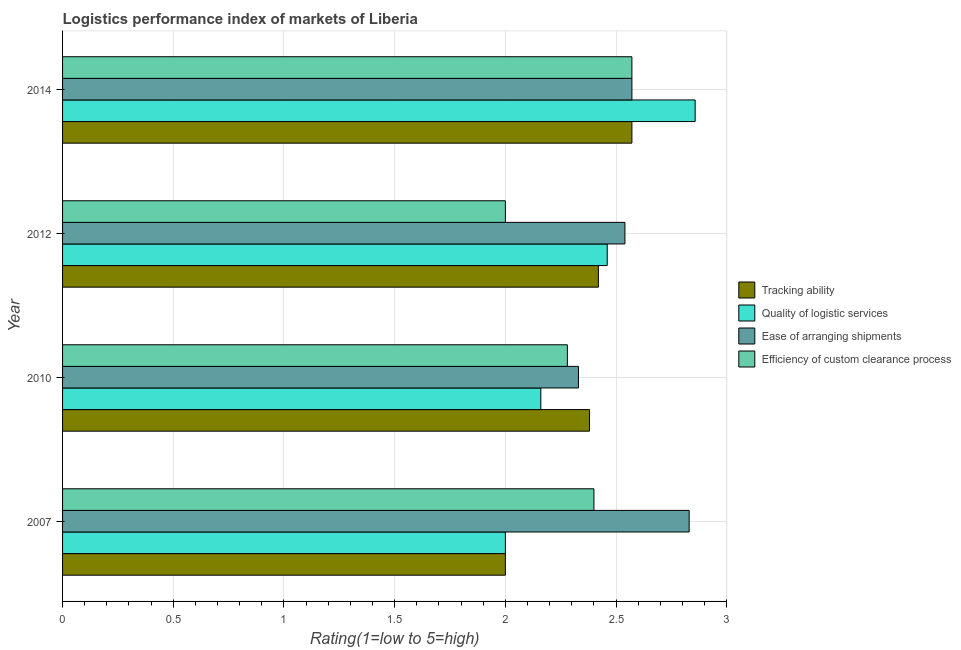How many groups of bars are there?
Keep it short and to the point. 4. Are the number of bars on each tick of the Y-axis equal?
Give a very brief answer. Yes. What is the lpi rating of quality of logistic services in 2012?
Make the answer very short. 2.46. Across all years, what is the maximum lpi rating of ease of arranging shipments?
Offer a very short reply. 2.83. In which year was the lpi rating of ease of arranging shipments minimum?
Provide a succinct answer. 2010. What is the total lpi rating of tracking ability in the graph?
Offer a terse response. 9.37. What is the difference between the lpi rating of tracking ability in 2007 and that in 2010?
Offer a terse response. -0.38. What is the difference between the lpi rating of quality of logistic services in 2012 and the lpi rating of efficiency of custom clearance process in 2014?
Offer a terse response. -0.11. What is the average lpi rating of tracking ability per year?
Keep it short and to the point. 2.34. In the year 2012, what is the difference between the lpi rating of tracking ability and lpi rating of ease of arranging shipments?
Provide a short and direct response. -0.12. What is the ratio of the lpi rating of quality of logistic services in 2012 to that in 2014?
Provide a succinct answer. 0.86. Is the difference between the lpi rating of quality of logistic services in 2012 and 2014 greater than the difference between the lpi rating of efficiency of custom clearance process in 2012 and 2014?
Keep it short and to the point. Yes. What is the difference between the highest and the second highest lpi rating of tracking ability?
Your response must be concise. 0.15. What is the difference between the highest and the lowest lpi rating of quality of logistic services?
Your answer should be very brief. 0.86. In how many years, is the lpi rating of quality of logistic services greater than the average lpi rating of quality of logistic services taken over all years?
Offer a very short reply. 2. Is the sum of the lpi rating of tracking ability in 2007 and 2014 greater than the maximum lpi rating of ease of arranging shipments across all years?
Provide a short and direct response. Yes. Is it the case that in every year, the sum of the lpi rating of efficiency of custom clearance process and lpi rating of quality of logistic services is greater than the sum of lpi rating of tracking ability and lpi rating of ease of arranging shipments?
Offer a terse response. No. What does the 2nd bar from the top in 2010 represents?
Your answer should be very brief. Ease of arranging shipments. What does the 1st bar from the bottom in 2012 represents?
Your answer should be compact. Tracking ability. Are all the bars in the graph horizontal?
Offer a terse response. Yes. How many years are there in the graph?
Offer a very short reply. 4. Does the graph contain any zero values?
Ensure brevity in your answer.  No. Does the graph contain grids?
Keep it short and to the point. Yes. How many legend labels are there?
Offer a very short reply. 4. How are the legend labels stacked?
Make the answer very short. Vertical. What is the title of the graph?
Ensure brevity in your answer.  Logistics performance index of markets of Liberia. Does "Public resource use" appear as one of the legend labels in the graph?
Offer a very short reply. No. What is the label or title of the X-axis?
Make the answer very short. Rating(1=low to 5=high). What is the label or title of the Y-axis?
Make the answer very short. Year. What is the Rating(1=low to 5=high) in Tracking ability in 2007?
Give a very brief answer. 2. What is the Rating(1=low to 5=high) of Quality of logistic services in 2007?
Give a very brief answer. 2. What is the Rating(1=low to 5=high) of Ease of arranging shipments in 2007?
Offer a terse response. 2.83. What is the Rating(1=low to 5=high) in Efficiency of custom clearance process in 2007?
Give a very brief answer. 2.4. What is the Rating(1=low to 5=high) in Tracking ability in 2010?
Keep it short and to the point. 2.38. What is the Rating(1=low to 5=high) in Quality of logistic services in 2010?
Provide a succinct answer. 2.16. What is the Rating(1=low to 5=high) in Ease of arranging shipments in 2010?
Your response must be concise. 2.33. What is the Rating(1=low to 5=high) of Efficiency of custom clearance process in 2010?
Keep it short and to the point. 2.28. What is the Rating(1=low to 5=high) of Tracking ability in 2012?
Make the answer very short. 2.42. What is the Rating(1=low to 5=high) of Quality of logistic services in 2012?
Give a very brief answer. 2.46. What is the Rating(1=low to 5=high) in Ease of arranging shipments in 2012?
Keep it short and to the point. 2.54. What is the Rating(1=low to 5=high) in Efficiency of custom clearance process in 2012?
Offer a very short reply. 2. What is the Rating(1=low to 5=high) in Tracking ability in 2014?
Your answer should be compact. 2.57. What is the Rating(1=low to 5=high) of Quality of logistic services in 2014?
Provide a succinct answer. 2.86. What is the Rating(1=low to 5=high) in Ease of arranging shipments in 2014?
Offer a very short reply. 2.57. What is the Rating(1=low to 5=high) in Efficiency of custom clearance process in 2014?
Ensure brevity in your answer.  2.57. Across all years, what is the maximum Rating(1=low to 5=high) of Tracking ability?
Keep it short and to the point. 2.57. Across all years, what is the maximum Rating(1=low to 5=high) in Quality of logistic services?
Ensure brevity in your answer.  2.86. Across all years, what is the maximum Rating(1=low to 5=high) in Ease of arranging shipments?
Provide a succinct answer. 2.83. Across all years, what is the maximum Rating(1=low to 5=high) of Efficiency of custom clearance process?
Provide a succinct answer. 2.57. Across all years, what is the minimum Rating(1=low to 5=high) in Ease of arranging shipments?
Your answer should be very brief. 2.33. Across all years, what is the minimum Rating(1=low to 5=high) of Efficiency of custom clearance process?
Offer a terse response. 2. What is the total Rating(1=low to 5=high) of Tracking ability in the graph?
Offer a terse response. 9.37. What is the total Rating(1=low to 5=high) of Quality of logistic services in the graph?
Keep it short and to the point. 9.48. What is the total Rating(1=low to 5=high) of Ease of arranging shipments in the graph?
Your response must be concise. 10.27. What is the total Rating(1=low to 5=high) of Efficiency of custom clearance process in the graph?
Keep it short and to the point. 9.25. What is the difference between the Rating(1=low to 5=high) of Tracking ability in 2007 and that in 2010?
Keep it short and to the point. -0.38. What is the difference between the Rating(1=low to 5=high) in Quality of logistic services in 2007 and that in 2010?
Give a very brief answer. -0.16. What is the difference between the Rating(1=low to 5=high) in Ease of arranging shipments in 2007 and that in 2010?
Provide a short and direct response. 0.5. What is the difference between the Rating(1=low to 5=high) of Efficiency of custom clearance process in 2007 and that in 2010?
Give a very brief answer. 0.12. What is the difference between the Rating(1=low to 5=high) of Tracking ability in 2007 and that in 2012?
Your answer should be compact. -0.42. What is the difference between the Rating(1=low to 5=high) in Quality of logistic services in 2007 and that in 2012?
Ensure brevity in your answer.  -0.46. What is the difference between the Rating(1=low to 5=high) in Ease of arranging shipments in 2007 and that in 2012?
Provide a succinct answer. 0.29. What is the difference between the Rating(1=low to 5=high) in Efficiency of custom clearance process in 2007 and that in 2012?
Ensure brevity in your answer.  0.4. What is the difference between the Rating(1=low to 5=high) of Tracking ability in 2007 and that in 2014?
Your response must be concise. -0.57. What is the difference between the Rating(1=low to 5=high) in Quality of logistic services in 2007 and that in 2014?
Provide a succinct answer. -0.86. What is the difference between the Rating(1=low to 5=high) in Ease of arranging shipments in 2007 and that in 2014?
Your answer should be compact. 0.26. What is the difference between the Rating(1=low to 5=high) in Efficiency of custom clearance process in 2007 and that in 2014?
Offer a very short reply. -0.17. What is the difference between the Rating(1=low to 5=high) in Tracking ability in 2010 and that in 2012?
Keep it short and to the point. -0.04. What is the difference between the Rating(1=low to 5=high) of Ease of arranging shipments in 2010 and that in 2012?
Your response must be concise. -0.21. What is the difference between the Rating(1=low to 5=high) in Efficiency of custom clearance process in 2010 and that in 2012?
Provide a succinct answer. 0.28. What is the difference between the Rating(1=low to 5=high) in Tracking ability in 2010 and that in 2014?
Offer a very short reply. -0.19. What is the difference between the Rating(1=low to 5=high) in Quality of logistic services in 2010 and that in 2014?
Provide a succinct answer. -0.7. What is the difference between the Rating(1=low to 5=high) in Ease of arranging shipments in 2010 and that in 2014?
Your answer should be compact. -0.24. What is the difference between the Rating(1=low to 5=high) of Efficiency of custom clearance process in 2010 and that in 2014?
Give a very brief answer. -0.29. What is the difference between the Rating(1=low to 5=high) of Tracking ability in 2012 and that in 2014?
Offer a very short reply. -0.15. What is the difference between the Rating(1=low to 5=high) in Quality of logistic services in 2012 and that in 2014?
Make the answer very short. -0.4. What is the difference between the Rating(1=low to 5=high) of Ease of arranging shipments in 2012 and that in 2014?
Make the answer very short. -0.03. What is the difference between the Rating(1=low to 5=high) of Efficiency of custom clearance process in 2012 and that in 2014?
Your answer should be compact. -0.57. What is the difference between the Rating(1=low to 5=high) of Tracking ability in 2007 and the Rating(1=low to 5=high) of Quality of logistic services in 2010?
Give a very brief answer. -0.16. What is the difference between the Rating(1=low to 5=high) in Tracking ability in 2007 and the Rating(1=low to 5=high) in Ease of arranging shipments in 2010?
Your response must be concise. -0.33. What is the difference between the Rating(1=low to 5=high) in Tracking ability in 2007 and the Rating(1=low to 5=high) in Efficiency of custom clearance process in 2010?
Ensure brevity in your answer.  -0.28. What is the difference between the Rating(1=low to 5=high) in Quality of logistic services in 2007 and the Rating(1=low to 5=high) in Ease of arranging shipments in 2010?
Make the answer very short. -0.33. What is the difference between the Rating(1=low to 5=high) in Quality of logistic services in 2007 and the Rating(1=low to 5=high) in Efficiency of custom clearance process in 2010?
Your answer should be very brief. -0.28. What is the difference between the Rating(1=low to 5=high) of Ease of arranging shipments in 2007 and the Rating(1=low to 5=high) of Efficiency of custom clearance process in 2010?
Ensure brevity in your answer.  0.55. What is the difference between the Rating(1=low to 5=high) of Tracking ability in 2007 and the Rating(1=low to 5=high) of Quality of logistic services in 2012?
Offer a very short reply. -0.46. What is the difference between the Rating(1=low to 5=high) in Tracking ability in 2007 and the Rating(1=low to 5=high) in Ease of arranging shipments in 2012?
Provide a succinct answer. -0.54. What is the difference between the Rating(1=low to 5=high) of Quality of logistic services in 2007 and the Rating(1=low to 5=high) of Ease of arranging shipments in 2012?
Offer a terse response. -0.54. What is the difference between the Rating(1=low to 5=high) in Quality of logistic services in 2007 and the Rating(1=low to 5=high) in Efficiency of custom clearance process in 2012?
Provide a short and direct response. 0. What is the difference between the Rating(1=low to 5=high) in Ease of arranging shipments in 2007 and the Rating(1=low to 5=high) in Efficiency of custom clearance process in 2012?
Your response must be concise. 0.83. What is the difference between the Rating(1=low to 5=high) in Tracking ability in 2007 and the Rating(1=low to 5=high) in Quality of logistic services in 2014?
Keep it short and to the point. -0.86. What is the difference between the Rating(1=low to 5=high) in Tracking ability in 2007 and the Rating(1=low to 5=high) in Ease of arranging shipments in 2014?
Provide a short and direct response. -0.57. What is the difference between the Rating(1=low to 5=high) of Tracking ability in 2007 and the Rating(1=low to 5=high) of Efficiency of custom clearance process in 2014?
Give a very brief answer. -0.57. What is the difference between the Rating(1=low to 5=high) in Quality of logistic services in 2007 and the Rating(1=low to 5=high) in Ease of arranging shipments in 2014?
Ensure brevity in your answer.  -0.57. What is the difference between the Rating(1=low to 5=high) in Quality of logistic services in 2007 and the Rating(1=low to 5=high) in Efficiency of custom clearance process in 2014?
Offer a very short reply. -0.57. What is the difference between the Rating(1=low to 5=high) of Ease of arranging shipments in 2007 and the Rating(1=low to 5=high) of Efficiency of custom clearance process in 2014?
Make the answer very short. 0.26. What is the difference between the Rating(1=low to 5=high) of Tracking ability in 2010 and the Rating(1=low to 5=high) of Quality of logistic services in 2012?
Your answer should be very brief. -0.08. What is the difference between the Rating(1=low to 5=high) of Tracking ability in 2010 and the Rating(1=low to 5=high) of Ease of arranging shipments in 2012?
Provide a succinct answer. -0.16. What is the difference between the Rating(1=low to 5=high) of Tracking ability in 2010 and the Rating(1=low to 5=high) of Efficiency of custom clearance process in 2012?
Give a very brief answer. 0.38. What is the difference between the Rating(1=low to 5=high) in Quality of logistic services in 2010 and the Rating(1=low to 5=high) in Ease of arranging shipments in 2012?
Offer a terse response. -0.38. What is the difference between the Rating(1=low to 5=high) of Quality of logistic services in 2010 and the Rating(1=low to 5=high) of Efficiency of custom clearance process in 2012?
Keep it short and to the point. 0.16. What is the difference between the Rating(1=low to 5=high) in Ease of arranging shipments in 2010 and the Rating(1=low to 5=high) in Efficiency of custom clearance process in 2012?
Make the answer very short. 0.33. What is the difference between the Rating(1=low to 5=high) of Tracking ability in 2010 and the Rating(1=low to 5=high) of Quality of logistic services in 2014?
Provide a succinct answer. -0.48. What is the difference between the Rating(1=low to 5=high) of Tracking ability in 2010 and the Rating(1=low to 5=high) of Ease of arranging shipments in 2014?
Your response must be concise. -0.19. What is the difference between the Rating(1=low to 5=high) of Tracking ability in 2010 and the Rating(1=low to 5=high) of Efficiency of custom clearance process in 2014?
Provide a succinct answer. -0.19. What is the difference between the Rating(1=low to 5=high) of Quality of logistic services in 2010 and the Rating(1=low to 5=high) of Ease of arranging shipments in 2014?
Offer a terse response. -0.41. What is the difference between the Rating(1=low to 5=high) of Quality of logistic services in 2010 and the Rating(1=low to 5=high) of Efficiency of custom clearance process in 2014?
Your answer should be very brief. -0.41. What is the difference between the Rating(1=low to 5=high) of Ease of arranging shipments in 2010 and the Rating(1=low to 5=high) of Efficiency of custom clearance process in 2014?
Ensure brevity in your answer.  -0.24. What is the difference between the Rating(1=low to 5=high) in Tracking ability in 2012 and the Rating(1=low to 5=high) in Quality of logistic services in 2014?
Your answer should be compact. -0.44. What is the difference between the Rating(1=low to 5=high) in Tracking ability in 2012 and the Rating(1=low to 5=high) in Ease of arranging shipments in 2014?
Provide a short and direct response. -0.15. What is the difference between the Rating(1=low to 5=high) of Tracking ability in 2012 and the Rating(1=low to 5=high) of Efficiency of custom clearance process in 2014?
Your answer should be compact. -0.15. What is the difference between the Rating(1=low to 5=high) of Quality of logistic services in 2012 and the Rating(1=low to 5=high) of Ease of arranging shipments in 2014?
Offer a very short reply. -0.11. What is the difference between the Rating(1=low to 5=high) of Quality of logistic services in 2012 and the Rating(1=low to 5=high) of Efficiency of custom clearance process in 2014?
Ensure brevity in your answer.  -0.11. What is the difference between the Rating(1=low to 5=high) in Ease of arranging shipments in 2012 and the Rating(1=low to 5=high) in Efficiency of custom clearance process in 2014?
Provide a succinct answer. -0.03. What is the average Rating(1=low to 5=high) in Tracking ability per year?
Give a very brief answer. 2.34. What is the average Rating(1=low to 5=high) in Quality of logistic services per year?
Your response must be concise. 2.37. What is the average Rating(1=low to 5=high) of Ease of arranging shipments per year?
Offer a terse response. 2.57. What is the average Rating(1=low to 5=high) in Efficiency of custom clearance process per year?
Ensure brevity in your answer.  2.31. In the year 2007, what is the difference between the Rating(1=low to 5=high) in Tracking ability and Rating(1=low to 5=high) in Quality of logistic services?
Ensure brevity in your answer.  0. In the year 2007, what is the difference between the Rating(1=low to 5=high) of Tracking ability and Rating(1=low to 5=high) of Ease of arranging shipments?
Provide a succinct answer. -0.83. In the year 2007, what is the difference between the Rating(1=low to 5=high) in Tracking ability and Rating(1=low to 5=high) in Efficiency of custom clearance process?
Offer a terse response. -0.4. In the year 2007, what is the difference between the Rating(1=low to 5=high) in Quality of logistic services and Rating(1=low to 5=high) in Ease of arranging shipments?
Give a very brief answer. -0.83. In the year 2007, what is the difference between the Rating(1=low to 5=high) of Ease of arranging shipments and Rating(1=low to 5=high) of Efficiency of custom clearance process?
Ensure brevity in your answer.  0.43. In the year 2010, what is the difference between the Rating(1=low to 5=high) of Tracking ability and Rating(1=low to 5=high) of Quality of logistic services?
Offer a terse response. 0.22. In the year 2010, what is the difference between the Rating(1=low to 5=high) in Tracking ability and Rating(1=low to 5=high) in Efficiency of custom clearance process?
Provide a succinct answer. 0.1. In the year 2010, what is the difference between the Rating(1=low to 5=high) of Quality of logistic services and Rating(1=low to 5=high) of Ease of arranging shipments?
Make the answer very short. -0.17. In the year 2010, what is the difference between the Rating(1=low to 5=high) of Quality of logistic services and Rating(1=low to 5=high) of Efficiency of custom clearance process?
Keep it short and to the point. -0.12. In the year 2012, what is the difference between the Rating(1=low to 5=high) in Tracking ability and Rating(1=low to 5=high) in Quality of logistic services?
Offer a terse response. -0.04. In the year 2012, what is the difference between the Rating(1=low to 5=high) of Tracking ability and Rating(1=low to 5=high) of Ease of arranging shipments?
Your answer should be very brief. -0.12. In the year 2012, what is the difference between the Rating(1=low to 5=high) of Tracking ability and Rating(1=low to 5=high) of Efficiency of custom clearance process?
Offer a terse response. 0.42. In the year 2012, what is the difference between the Rating(1=low to 5=high) in Quality of logistic services and Rating(1=low to 5=high) in Ease of arranging shipments?
Ensure brevity in your answer.  -0.08. In the year 2012, what is the difference between the Rating(1=low to 5=high) in Quality of logistic services and Rating(1=low to 5=high) in Efficiency of custom clearance process?
Give a very brief answer. 0.46. In the year 2012, what is the difference between the Rating(1=low to 5=high) of Ease of arranging shipments and Rating(1=low to 5=high) of Efficiency of custom clearance process?
Provide a succinct answer. 0.54. In the year 2014, what is the difference between the Rating(1=low to 5=high) of Tracking ability and Rating(1=low to 5=high) of Quality of logistic services?
Your answer should be very brief. -0.29. In the year 2014, what is the difference between the Rating(1=low to 5=high) in Tracking ability and Rating(1=low to 5=high) in Ease of arranging shipments?
Provide a succinct answer. 0. In the year 2014, what is the difference between the Rating(1=low to 5=high) of Tracking ability and Rating(1=low to 5=high) of Efficiency of custom clearance process?
Your answer should be very brief. 0. In the year 2014, what is the difference between the Rating(1=low to 5=high) of Quality of logistic services and Rating(1=low to 5=high) of Ease of arranging shipments?
Offer a terse response. 0.29. In the year 2014, what is the difference between the Rating(1=low to 5=high) in Quality of logistic services and Rating(1=low to 5=high) in Efficiency of custom clearance process?
Give a very brief answer. 0.29. In the year 2014, what is the difference between the Rating(1=low to 5=high) of Ease of arranging shipments and Rating(1=low to 5=high) of Efficiency of custom clearance process?
Give a very brief answer. 0. What is the ratio of the Rating(1=low to 5=high) in Tracking ability in 2007 to that in 2010?
Make the answer very short. 0.84. What is the ratio of the Rating(1=low to 5=high) in Quality of logistic services in 2007 to that in 2010?
Provide a succinct answer. 0.93. What is the ratio of the Rating(1=low to 5=high) in Ease of arranging shipments in 2007 to that in 2010?
Keep it short and to the point. 1.21. What is the ratio of the Rating(1=low to 5=high) of Efficiency of custom clearance process in 2007 to that in 2010?
Your answer should be very brief. 1.05. What is the ratio of the Rating(1=low to 5=high) of Tracking ability in 2007 to that in 2012?
Provide a short and direct response. 0.83. What is the ratio of the Rating(1=low to 5=high) of Quality of logistic services in 2007 to that in 2012?
Your answer should be compact. 0.81. What is the ratio of the Rating(1=low to 5=high) in Ease of arranging shipments in 2007 to that in 2012?
Offer a terse response. 1.11. What is the ratio of the Rating(1=low to 5=high) of Tracking ability in 2007 to that in 2014?
Ensure brevity in your answer.  0.78. What is the ratio of the Rating(1=low to 5=high) in Ease of arranging shipments in 2007 to that in 2014?
Offer a terse response. 1.1. What is the ratio of the Rating(1=low to 5=high) in Tracking ability in 2010 to that in 2012?
Your answer should be very brief. 0.98. What is the ratio of the Rating(1=low to 5=high) in Quality of logistic services in 2010 to that in 2012?
Provide a succinct answer. 0.88. What is the ratio of the Rating(1=low to 5=high) of Ease of arranging shipments in 2010 to that in 2012?
Offer a very short reply. 0.92. What is the ratio of the Rating(1=low to 5=high) of Efficiency of custom clearance process in 2010 to that in 2012?
Your response must be concise. 1.14. What is the ratio of the Rating(1=low to 5=high) of Tracking ability in 2010 to that in 2014?
Your response must be concise. 0.93. What is the ratio of the Rating(1=low to 5=high) in Quality of logistic services in 2010 to that in 2014?
Provide a succinct answer. 0.76. What is the ratio of the Rating(1=low to 5=high) in Ease of arranging shipments in 2010 to that in 2014?
Your response must be concise. 0.91. What is the ratio of the Rating(1=low to 5=high) in Efficiency of custom clearance process in 2010 to that in 2014?
Your answer should be compact. 0.89. What is the ratio of the Rating(1=low to 5=high) in Tracking ability in 2012 to that in 2014?
Your answer should be very brief. 0.94. What is the ratio of the Rating(1=low to 5=high) of Quality of logistic services in 2012 to that in 2014?
Make the answer very short. 0.86. What is the ratio of the Rating(1=low to 5=high) in Efficiency of custom clearance process in 2012 to that in 2014?
Your answer should be very brief. 0.78. What is the difference between the highest and the second highest Rating(1=low to 5=high) of Tracking ability?
Offer a very short reply. 0.15. What is the difference between the highest and the second highest Rating(1=low to 5=high) in Quality of logistic services?
Your response must be concise. 0.4. What is the difference between the highest and the second highest Rating(1=low to 5=high) in Ease of arranging shipments?
Your answer should be very brief. 0.26. What is the difference between the highest and the second highest Rating(1=low to 5=high) in Efficiency of custom clearance process?
Keep it short and to the point. 0.17. What is the difference between the highest and the lowest Rating(1=low to 5=high) in Tracking ability?
Your answer should be very brief. 0.57. What is the difference between the highest and the lowest Rating(1=low to 5=high) in Efficiency of custom clearance process?
Offer a terse response. 0.57. 